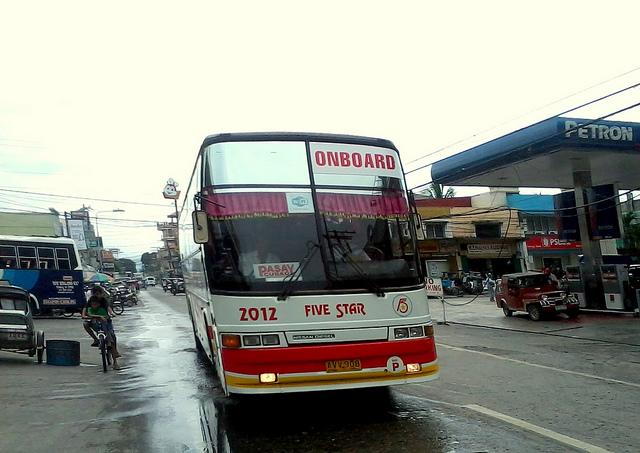Are the buses passing through a lonely neighbourhood?
Write a very short answer. No. What kind of property is advertised to the left?
Keep it brief. Bus. Is there a cyclist in the picture?
Keep it brief. Yes. Is there a gas station nearby?
Give a very brief answer. Yes. What kind of business is the sign advertising on the right side of the image, closest to the viewer?
Give a very brief answer. Gas station. What number is on the front of this bus?
Be succinct. 2012. What type of bus is on the street?
Give a very brief answer. Five star. What number is written on the bus?
Short answer required. 2012. What time was the pic taken?
Give a very brief answer. Noon. What number is in on the bus that is four digits?
Write a very short answer. 2012. What is the number on the bus?
Concise answer only. 2012. 